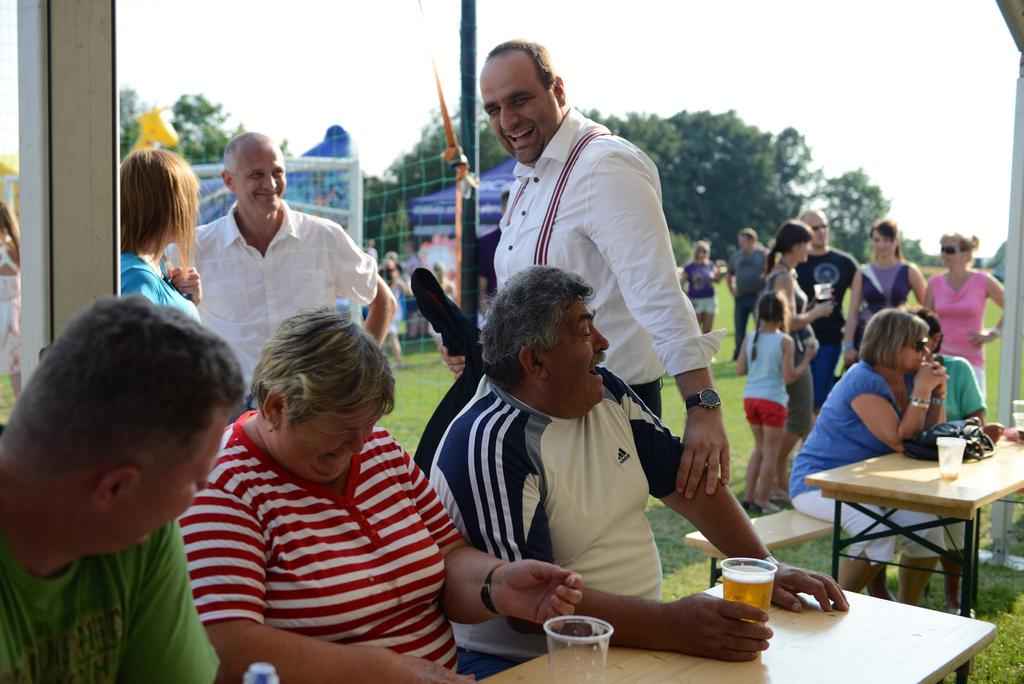Who is in the image? There are people in the image. What are the people doing? The people are smiling. What is on the table in the image? There is a wooden table in the image, and glasses are present on the table. What can be seen in the background of the image? There is a tree and a net in the background of the image. Are there any other people visible in the image? Yes, there are people in the background of the image. What type of fog can be seen in the image? There is no fog present in the image. How do the boats in the image affect the people's activities? There are no boats present in the image, so their impact on the people's activities cannot be determined. 